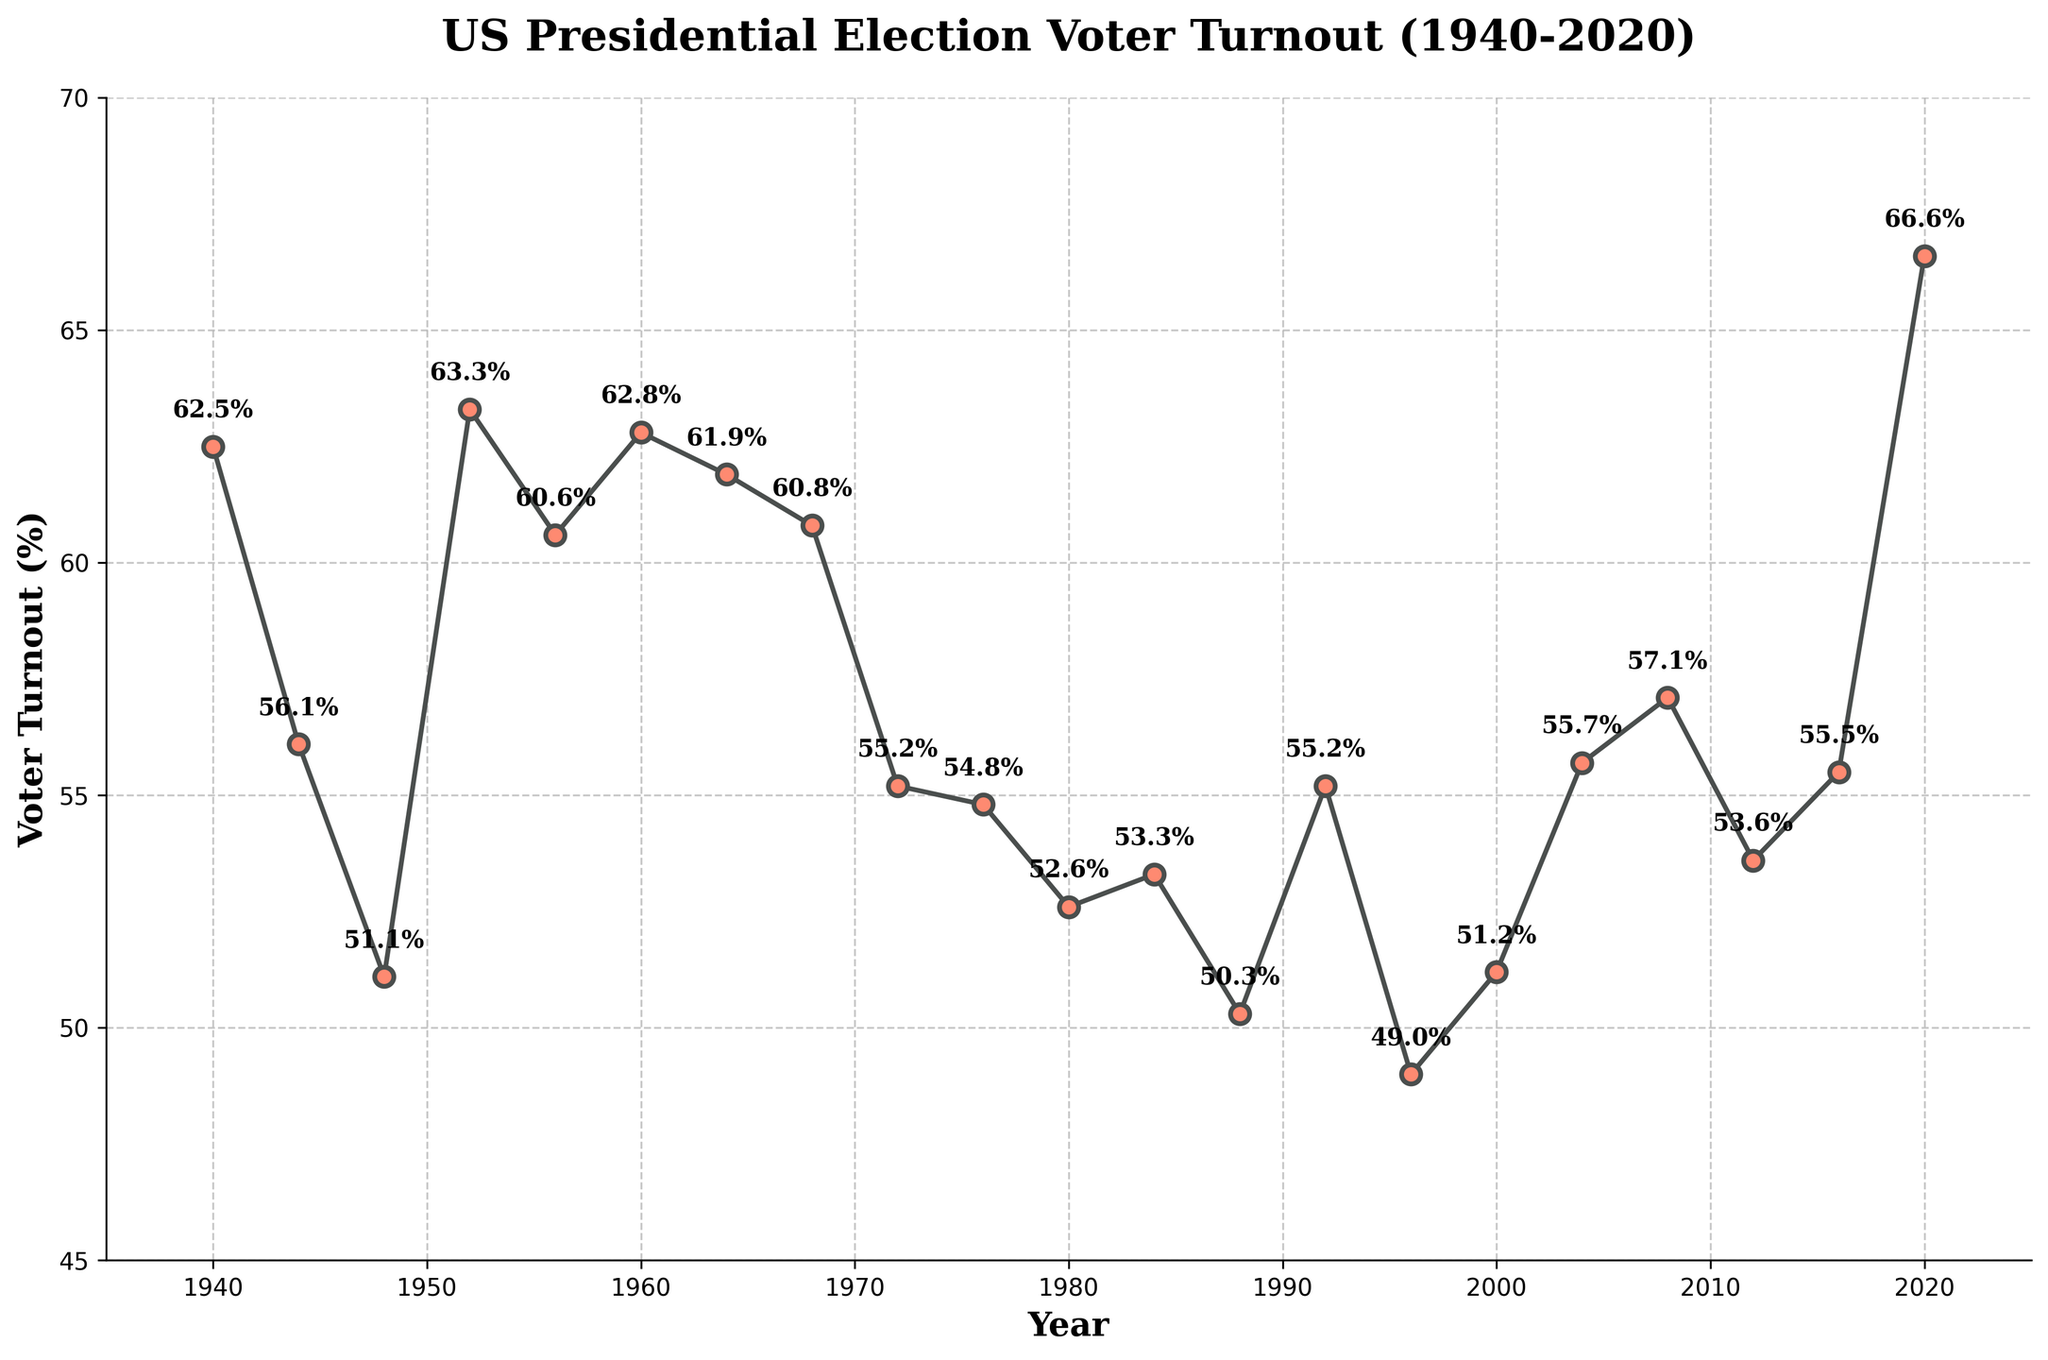What is the title of the plot? The title of the plot is displayed at the top of the figure. It reads "US Presidential Election Voter Turnout (1940-2020)".
Answer: US Presidential Election Voter Turnout (1940-2020) What is the voter turnout percentage in 1944? Locate the year 1944 on the x-axis and move up to the corresponding data point. The turnout percentage is labeled next to it.
Answer: 56.1% Which year had the highest voter turnout percentage? Identify the data point that is highest on the y-axis and read the corresponding year and value. It occurs in 2020 with 66.6%.
Answer: 2020 How did the voter turnout change between 2000 and 2004? Find the voter turnout percentages for both 2000 (51.2%) and 2004 (55.7%) and calculate the difference. The percentage increased by 4.5%.
Answer: Increased by 4.5% What was the voter turnout percentage in 1988, and how does it compare to that in 1996? Find the percentages for 1988 (50.3%) and 1996 (49.0%). Compare the two values; 1988's turnout is 1.3% higher than in 1996.
Answer: 50.3%, 1.3% higher than in 1996 What's the average voter turnout percentage from 1940 to 2020? Add up all the voter turnout percentages from 1940 to 2020 and divide by the number of data points (21 years). (62.5 + 56.1 + 51.1 + 63.3 + 60.6 + 62.8 + 61.9 + 60.8 + 55.2 + 54.8 + 52.6 + 53.3 + 50.3 + 55.2 + 49.0 + 51.2 + 55.7 + 57.1 + 53.6 + 55.5 + 66.6) / 21 ≈ 56.1%
Answer: 56.1% Which decades show a general decrease in voter turnout percentage? Examine the plot to see how the voter turnout percentage changes over different decades. The periods from 1956-1968 and 1984-2000 show general decreasing trends.
Answer: 1956-1968, 1984-2000 What is the difference in voter turnout percentage between 1964 and 1968? Find the voter turnout percentages in 1964 (61.9%) and 1968 (60.8%) and calculate the difference. The difference is 61.9% - 60.8% = 1.1%.
Answer: 1.1% Which two consecutive years show the largest drop in voter turnout percentage? Compare the differences in voter turnout percentages between consecutive election years throughout the plot. The largest drop is between 1960 (62.8%) and 1964 (61.9%), a decrease of 6.7%.
Answer: 1960 to 1964 